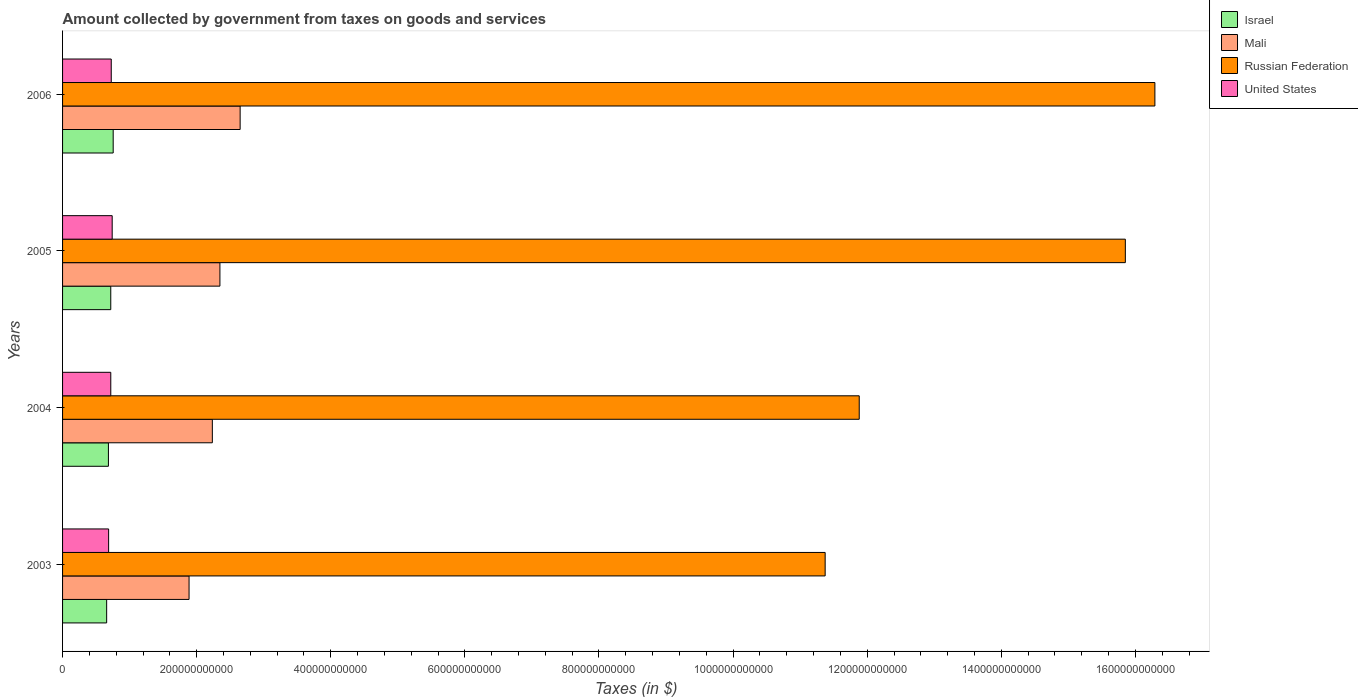How many different coloured bars are there?
Provide a succinct answer. 4. How many groups of bars are there?
Give a very brief answer. 4. Are the number of bars per tick equal to the number of legend labels?
Ensure brevity in your answer.  Yes. Are the number of bars on each tick of the Y-axis equal?
Provide a short and direct response. Yes. How many bars are there on the 2nd tick from the top?
Provide a short and direct response. 4. How many bars are there on the 1st tick from the bottom?
Your answer should be very brief. 4. What is the label of the 4th group of bars from the top?
Your response must be concise. 2003. What is the amount collected by government from taxes on goods and services in United States in 2004?
Your response must be concise. 7.19e+1. Across all years, what is the maximum amount collected by government from taxes on goods and services in Mali?
Offer a very short reply. 2.65e+11. Across all years, what is the minimum amount collected by government from taxes on goods and services in Russian Federation?
Your answer should be compact. 1.14e+12. What is the total amount collected by government from taxes on goods and services in Mali in the graph?
Your answer should be compact. 9.12e+11. What is the difference between the amount collected by government from taxes on goods and services in Russian Federation in 2003 and that in 2004?
Ensure brevity in your answer.  -5.08e+1. What is the difference between the amount collected by government from taxes on goods and services in Mali in 2005 and the amount collected by government from taxes on goods and services in United States in 2003?
Provide a succinct answer. 1.66e+11. What is the average amount collected by government from taxes on goods and services in Mali per year?
Make the answer very short. 2.28e+11. In the year 2004, what is the difference between the amount collected by government from taxes on goods and services in Russian Federation and amount collected by government from taxes on goods and services in Israel?
Provide a succinct answer. 1.12e+12. What is the ratio of the amount collected by government from taxes on goods and services in Israel in 2003 to that in 2005?
Give a very brief answer. 0.91. Is the difference between the amount collected by government from taxes on goods and services in Russian Federation in 2003 and 2004 greater than the difference between the amount collected by government from taxes on goods and services in Israel in 2003 and 2004?
Ensure brevity in your answer.  No. What is the difference between the highest and the second highest amount collected by government from taxes on goods and services in Mali?
Give a very brief answer. 3.02e+1. What is the difference between the highest and the lowest amount collected by government from taxes on goods and services in Israel?
Your answer should be very brief. 9.73e+09. Is it the case that in every year, the sum of the amount collected by government from taxes on goods and services in Mali and amount collected by government from taxes on goods and services in United States is greater than the sum of amount collected by government from taxes on goods and services in Israel and amount collected by government from taxes on goods and services in Russian Federation?
Offer a terse response. Yes. What does the 3rd bar from the top in 2004 represents?
Your answer should be very brief. Mali. What does the 3rd bar from the bottom in 2003 represents?
Provide a short and direct response. Russian Federation. How many years are there in the graph?
Keep it short and to the point. 4. What is the difference between two consecutive major ticks on the X-axis?
Your answer should be compact. 2.00e+11. Are the values on the major ticks of X-axis written in scientific E-notation?
Give a very brief answer. No. How many legend labels are there?
Offer a terse response. 4. How are the legend labels stacked?
Provide a short and direct response. Vertical. What is the title of the graph?
Offer a very short reply. Amount collected by government from taxes on goods and services. What is the label or title of the X-axis?
Provide a short and direct response. Taxes (in $). What is the Taxes (in $) in Israel in 2003?
Provide a short and direct response. 6.58e+1. What is the Taxes (in $) in Mali in 2003?
Provide a short and direct response. 1.89e+11. What is the Taxes (in $) of Russian Federation in 2003?
Give a very brief answer. 1.14e+12. What is the Taxes (in $) in United States in 2003?
Your answer should be very brief. 6.87e+1. What is the Taxes (in $) in Israel in 2004?
Ensure brevity in your answer.  6.84e+1. What is the Taxes (in $) in Mali in 2004?
Provide a short and direct response. 2.23e+11. What is the Taxes (in $) in Russian Federation in 2004?
Give a very brief answer. 1.19e+12. What is the Taxes (in $) in United States in 2004?
Keep it short and to the point. 7.19e+1. What is the Taxes (in $) of Israel in 2005?
Your response must be concise. 7.19e+1. What is the Taxes (in $) in Mali in 2005?
Make the answer very short. 2.35e+11. What is the Taxes (in $) in Russian Federation in 2005?
Offer a terse response. 1.59e+12. What is the Taxes (in $) in United States in 2005?
Provide a short and direct response. 7.40e+1. What is the Taxes (in $) of Israel in 2006?
Offer a terse response. 7.55e+1. What is the Taxes (in $) of Mali in 2006?
Provide a succinct answer. 2.65e+11. What is the Taxes (in $) in Russian Federation in 2006?
Give a very brief answer. 1.63e+12. What is the Taxes (in $) in United States in 2006?
Offer a terse response. 7.26e+1. Across all years, what is the maximum Taxes (in $) in Israel?
Your response must be concise. 7.55e+1. Across all years, what is the maximum Taxes (in $) of Mali?
Provide a succinct answer. 2.65e+11. Across all years, what is the maximum Taxes (in $) of Russian Federation?
Make the answer very short. 1.63e+12. Across all years, what is the maximum Taxes (in $) in United States?
Your answer should be compact. 7.40e+1. Across all years, what is the minimum Taxes (in $) of Israel?
Keep it short and to the point. 6.58e+1. Across all years, what is the minimum Taxes (in $) of Mali?
Keep it short and to the point. 1.89e+11. Across all years, what is the minimum Taxes (in $) in Russian Federation?
Your answer should be very brief. 1.14e+12. Across all years, what is the minimum Taxes (in $) of United States?
Your response must be concise. 6.87e+1. What is the total Taxes (in $) of Israel in the graph?
Your answer should be very brief. 2.82e+11. What is the total Taxes (in $) of Mali in the graph?
Provide a short and direct response. 9.12e+11. What is the total Taxes (in $) of Russian Federation in the graph?
Your response must be concise. 5.54e+12. What is the total Taxes (in $) of United States in the graph?
Offer a very short reply. 2.87e+11. What is the difference between the Taxes (in $) of Israel in 2003 and that in 2004?
Give a very brief answer. -2.62e+09. What is the difference between the Taxes (in $) of Mali in 2003 and that in 2004?
Ensure brevity in your answer.  -3.47e+1. What is the difference between the Taxes (in $) of Russian Federation in 2003 and that in 2004?
Make the answer very short. -5.08e+1. What is the difference between the Taxes (in $) in United States in 2003 and that in 2004?
Provide a short and direct response. -3.20e+09. What is the difference between the Taxes (in $) in Israel in 2003 and that in 2005?
Offer a very short reply. -6.11e+09. What is the difference between the Taxes (in $) in Mali in 2003 and that in 2005?
Your answer should be very brief. -4.60e+1. What is the difference between the Taxes (in $) of Russian Federation in 2003 and that in 2005?
Offer a terse response. -4.48e+11. What is the difference between the Taxes (in $) in United States in 2003 and that in 2005?
Your answer should be very brief. -5.30e+09. What is the difference between the Taxes (in $) in Israel in 2003 and that in 2006?
Provide a succinct answer. -9.73e+09. What is the difference between the Taxes (in $) of Mali in 2003 and that in 2006?
Make the answer very short. -7.62e+1. What is the difference between the Taxes (in $) of Russian Federation in 2003 and that in 2006?
Give a very brief answer. -4.92e+11. What is the difference between the Taxes (in $) of United States in 2003 and that in 2006?
Provide a succinct answer. -3.90e+09. What is the difference between the Taxes (in $) in Israel in 2004 and that in 2005?
Offer a terse response. -3.50e+09. What is the difference between the Taxes (in $) of Mali in 2004 and that in 2005?
Your response must be concise. -1.13e+1. What is the difference between the Taxes (in $) in Russian Federation in 2004 and that in 2005?
Your answer should be compact. -3.97e+11. What is the difference between the Taxes (in $) in United States in 2004 and that in 2005?
Provide a short and direct response. -2.10e+09. What is the difference between the Taxes (in $) in Israel in 2004 and that in 2006?
Provide a succinct answer. -7.12e+09. What is the difference between the Taxes (in $) in Mali in 2004 and that in 2006?
Your answer should be compact. -4.14e+1. What is the difference between the Taxes (in $) of Russian Federation in 2004 and that in 2006?
Your answer should be very brief. -4.41e+11. What is the difference between the Taxes (in $) in United States in 2004 and that in 2006?
Give a very brief answer. -7.00e+08. What is the difference between the Taxes (in $) in Israel in 2005 and that in 2006?
Give a very brief answer. -3.62e+09. What is the difference between the Taxes (in $) of Mali in 2005 and that in 2006?
Provide a succinct answer. -3.02e+1. What is the difference between the Taxes (in $) of Russian Federation in 2005 and that in 2006?
Your response must be concise. -4.41e+1. What is the difference between the Taxes (in $) in United States in 2005 and that in 2006?
Your answer should be compact. 1.40e+09. What is the difference between the Taxes (in $) in Israel in 2003 and the Taxes (in $) in Mali in 2004?
Provide a succinct answer. -1.58e+11. What is the difference between the Taxes (in $) of Israel in 2003 and the Taxes (in $) of Russian Federation in 2004?
Make the answer very short. -1.12e+12. What is the difference between the Taxes (in $) in Israel in 2003 and the Taxes (in $) in United States in 2004?
Offer a terse response. -6.13e+09. What is the difference between the Taxes (in $) in Mali in 2003 and the Taxes (in $) in Russian Federation in 2004?
Make the answer very short. -9.99e+11. What is the difference between the Taxes (in $) of Mali in 2003 and the Taxes (in $) of United States in 2004?
Your answer should be very brief. 1.17e+11. What is the difference between the Taxes (in $) in Russian Federation in 2003 and the Taxes (in $) in United States in 2004?
Offer a terse response. 1.07e+12. What is the difference between the Taxes (in $) in Israel in 2003 and the Taxes (in $) in Mali in 2005?
Ensure brevity in your answer.  -1.69e+11. What is the difference between the Taxes (in $) of Israel in 2003 and the Taxes (in $) of Russian Federation in 2005?
Offer a terse response. -1.52e+12. What is the difference between the Taxes (in $) in Israel in 2003 and the Taxes (in $) in United States in 2005?
Offer a terse response. -8.23e+09. What is the difference between the Taxes (in $) of Mali in 2003 and the Taxes (in $) of Russian Federation in 2005?
Your answer should be very brief. -1.40e+12. What is the difference between the Taxes (in $) in Mali in 2003 and the Taxes (in $) in United States in 2005?
Provide a short and direct response. 1.15e+11. What is the difference between the Taxes (in $) in Russian Federation in 2003 and the Taxes (in $) in United States in 2005?
Your answer should be compact. 1.06e+12. What is the difference between the Taxes (in $) in Israel in 2003 and the Taxes (in $) in Mali in 2006?
Your answer should be very brief. -1.99e+11. What is the difference between the Taxes (in $) of Israel in 2003 and the Taxes (in $) of Russian Federation in 2006?
Give a very brief answer. -1.56e+12. What is the difference between the Taxes (in $) in Israel in 2003 and the Taxes (in $) in United States in 2006?
Offer a very short reply. -6.83e+09. What is the difference between the Taxes (in $) in Mali in 2003 and the Taxes (in $) in Russian Federation in 2006?
Your answer should be very brief. -1.44e+12. What is the difference between the Taxes (in $) of Mali in 2003 and the Taxes (in $) of United States in 2006?
Offer a terse response. 1.16e+11. What is the difference between the Taxes (in $) of Russian Federation in 2003 and the Taxes (in $) of United States in 2006?
Provide a succinct answer. 1.06e+12. What is the difference between the Taxes (in $) in Israel in 2004 and the Taxes (in $) in Mali in 2005?
Your answer should be compact. -1.66e+11. What is the difference between the Taxes (in $) in Israel in 2004 and the Taxes (in $) in Russian Federation in 2005?
Your answer should be compact. -1.52e+12. What is the difference between the Taxes (in $) of Israel in 2004 and the Taxes (in $) of United States in 2005?
Keep it short and to the point. -5.62e+09. What is the difference between the Taxes (in $) in Mali in 2004 and the Taxes (in $) in Russian Federation in 2005?
Make the answer very short. -1.36e+12. What is the difference between the Taxes (in $) in Mali in 2004 and the Taxes (in $) in United States in 2005?
Your answer should be very brief. 1.49e+11. What is the difference between the Taxes (in $) in Russian Federation in 2004 and the Taxes (in $) in United States in 2005?
Provide a succinct answer. 1.11e+12. What is the difference between the Taxes (in $) in Israel in 2004 and the Taxes (in $) in Mali in 2006?
Provide a short and direct response. -1.96e+11. What is the difference between the Taxes (in $) in Israel in 2004 and the Taxes (in $) in Russian Federation in 2006?
Your response must be concise. -1.56e+12. What is the difference between the Taxes (in $) of Israel in 2004 and the Taxes (in $) of United States in 2006?
Offer a very short reply. -4.22e+09. What is the difference between the Taxes (in $) of Mali in 2004 and the Taxes (in $) of Russian Federation in 2006?
Your response must be concise. -1.41e+12. What is the difference between the Taxes (in $) in Mali in 2004 and the Taxes (in $) in United States in 2006?
Give a very brief answer. 1.51e+11. What is the difference between the Taxes (in $) in Russian Federation in 2004 and the Taxes (in $) in United States in 2006?
Give a very brief answer. 1.12e+12. What is the difference between the Taxes (in $) in Israel in 2005 and the Taxes (in $) in Mali in 2006?
Provide a succinct answer. -1.93e+11. What is the difference between the Taxes (in $) in Israel in 2005 and the Taxes (in $) in Russian Federation in 2006?
Provide a succinct answer. -1.56e+12. What is the difference between the Taxes (in $) in Israel in 2005 and the Taxes (in $) in United States in 2006?
Your answer should be compact. -7.19e+08. What is the difference between the Taxes (in $) in Mali in 2005 and the Taxes (in $) in Russian Federation in 2006?
Make the answer very short. -1.39e+12. What is the difference between the Taxes (in $) of Mali in 2005 and the Taxes (in $) of United States in 2006?
Offer a terse response. 1.62e+11. What is the difference between the Taxes (in $) of Russian Federation in 2005 and the Taxes (in $) of United States in 2006?
Offer a very short reply. 1.51e+12. What is the average Taxes (in $) of Israel per year?
Ensure brevity in your answer.  7.04e+1. What is the average Taxes (in $) of Mali per year?
Your answer should be very brief. 2.28e+11. What is the average Taxes (in $) of Russian Federation per year?
Provide a short and direct response. 1.38e+12. What is the average Taxes (in $) in United States per year?
Provide a short and direct response. 7.18e+1. In the year 2003, what is the difference between the Taxes (in $) of Israel and Taxes (in $) of Mali?
Make the answer very short. -1.23e+11. In the year 2003, what is the difference between the Taxes (in $) of Israel and Taxes (in $) of Russian Federation?
Keep it short and to the point. -1.07e+12. In the year 2003, what is the difference between the Taxes (in $) of Israel and Taxes (in $) of United States?
Your answer should be very brief. -2.93e+09. In the year 2003, what is the difference between the Taxes (in $) of Mali and Taxes (in $) of Russian Federation?
Your answer should be very brief. -9.49e+11. In the year 2003, what is the difference between the Taxes (in $) in Mali and Taxes (in $) in United States?
Your response must be concise. 1.20e+11. In the year 2003, what is the difference between the Taxes (in $) in Russian Federation and Taxes (in $) in United States?
Offer a terse response. 1.07e+12. In the year 2004, what is the difference between the Taxes (in $) in Israel and Taxes (in $) in Mali?
Provide a short and direct response. -1.55e+11. In the year 2004, what is the difference between the Taxes (in $) in Israel and Taxes (in $) in Russian Federation?
Your response must be concise. -1.12e+12. In the year 2004, what is the difference between the Taxes (in $) in Israel and Taxes (in $) in United States?
Offer a terse response. -3.52e+09. In the year 2004, what is the difference between the Taxes (in $) of Mali and Taxes (in $) of Russian Federation?
Offer a very short reply. -9.65e+11. In the year 2004, what is the difference between the Taxes (in $) of Mali and Taxes (in $) of United States?
Your answer should be very brief. 1.51e+11. In the year 2004, what is the difference between the Taxes (in $) in Russian Federation and Taxes (in $) in United States?
Ensure brevity in your answer.  1.12e+12. In the year 2005, what is the difference between the Taxes (in $) of Israel and Taxes (in $) of Mali?
Ensure brevity in your answer.  -1.63e+11. In the year 2005, what is the difference between the Taxes (in $) of Israel and Taxes (in $) of Russian Federation?
Your answer should be compact. -1.51e+12. In the year 2005, what is the difference between the Taxes (in $) in Israel and Taxes (in $) in United States?
Ensure brevity in your answer.  -2.12e+09. In the year 2005, what is the difference between the Taxes (in $) in Mali and Taxes (in $) in Russian Federation?
Give a very brief answer. -1.35e+12. In the year 2005, what is the difference between the Taxes (in $) of Mali and Taxes (in $) of United States?
Your response must be concise. 1.61e+11. In the year 2005, what is the difference between the Taxes (in $) of Russian Federation and Taxes (in $) of United States?
Make the answer very short. 1.51e+12. In the year 2006, what is the difference between the Taxes (in $) of Israel and Taxes (in $) of Mali?
Your answer should be very brief. -1.89e+11. In the year 2006, what is the difference between the Taxes (in $) of Israel and Taxes (in $) of Russian Federation?
Provide a short and direct response. -1.55e+12. In the year 2006, what is the difference between the Taxes (in $) of Israel and Taxes (in $) of United States?
Provide a short and direct response. 2.90e+09. In the year 2006, what is the difference between the Taxes (in $) of Mali and Taxes (in $) of Russian Federation?
Your response must be concise. -1.36e+12. In the year 2006, what is the difference between the Taxes (in $) of Mali and Taxes (in $) of United States?
Keep it short and to the point. 1.92e+11. In the year 2006, what is the difference between the Taxes (in $) of Russian Federation and Taxes (in $) of United States?
Your answer should be very brief. 1.56e+12. What is the ratio of the Taxes (in $) in Israel in 2003 to that in 2004?
Give a very brief answer. 0.96. What is the ratio of the Taxes (in $) of Mali in 2003 to that in 2004?
Make the answer very short. 0.84. What is the ratio of the Taxes (in $) in Russian Federation in 2003 to that in 2004?
Make the answer very short. 0.96. What is the ratio of the Taxes (in $) in United States in 2003 to that in 2004?
Provide a short and direct response. 0.96. What is the ratio of the Taxes (in $) in Israel in 2003 to that in 2005?
Make the answer very short. 0.91. What is the ratio of the Taxes (in $) in Mali in 2003 to that in 2005?
Provide a short and direct response. 0.8. What is the ratio of the Taxes (in $) of Russian Federation in 2003 to that in 2005?
Give a very brief answer. 0.72. What is the ratio of the Taxes (in $) in United States in 2003 to that in 2005?
Provide a short and direct response. 0.93. What is the ratio of the Taxes (in $) in Israel in 2003 to that in 2006?
Your answer should be very brief. 0.87. What is the ratio of the Taxes (in $) of Mali in 2003 to that in 2006?
Provide a short and direct response. 0.71. What is the ratio of the Taxes (in $) in Russian Federation in 2003 to that in 2006?
Your answer should be compact. 0.7. What is the ratio of the Taxes (in $) in United States in 2003 to that in 2006?
Offer a very short reply. 0.95. What is the ratio of the Taxes (in $) in Israel in 2004 to that in 2005?
Offer a terse response. 0.95. What is the ratio of the Taxes (in $) of Mali in 2004 to that in 2005?
Your answer should be very brief. 0.95. What is the ratio of the Taxes (in $) in Russian Federation in 2004 to that in 2005?
Ensure brevity in your answer.  0.75. What is the ratio of the Taxes (in $) of United States in 2004 to that in 2005?
Your answer should be compact. 0.97. What is the ratio of the Taxes (in $) in Israel in 2004 to that in 2006?
Keep it short and to the point. 0.91. What is the ratio of the Taxes (in $) in Mali in 2004 to that in 2006?
Provide a succinct answer. 0.84. What is the ratio of the Taxes (in $) of Russian Federation in 2004 to that in 2006?
Keep it short and to the point. 0.73. What is the ratio of the Taxes (in $) in United States in 2004 to that in 2006?
Offer a terse response. 0.99. What is the ratio of the Taxes (in $) of Israel in 2005 to that in 2006?
Provide a short and direct response. 0.95. What is the ratio of the Taxes (in $) of Mali in 2005 to that in 2006?
Ensure brevity in your answer.  0.89. What is the ratio of the Taxes (in $) of Russian Federation in 2005 to that in 2006?
Ensure brevity in your answer.  0.97. What is the ratio of the Taxes (in $) in United States in 2005 to that in 2006?
Keep it short and to the point. 1.02. What is the difference between the highest and the second highest Taxes (in $) of Israel?
Provide a short and direct response. 3.62e+09. What is the difference between the highest and the second highest Taxes (in $) in Mali?
Offer a terse response. 3.02e+1. What is the difference between the highest and the second highest Taxes (in $) in Russian Federation?
Make the answer very short. 4.41e+1. What is the difference between the highest and the second highest Taxes (in $) in United States?
Give a very brief answer. 1.40e+09. What is the difference between the highest and the lowest Taxes (in $) in Israel?
Offer a terse response. 9.73e+09. What is the difference between the highest and the lowest Taxes (in $) in Mali?
Ensure brevity in your answer.  7.62e+1. What is the difference between the highest and the lowest Taxes (in $) in Russian Federation?
Give a very brief answer. 4.92e+11. What is the difference between the highest and the lowest Taxes (in $) of United States?
Provide a short and direct response. 5.30e+09. 